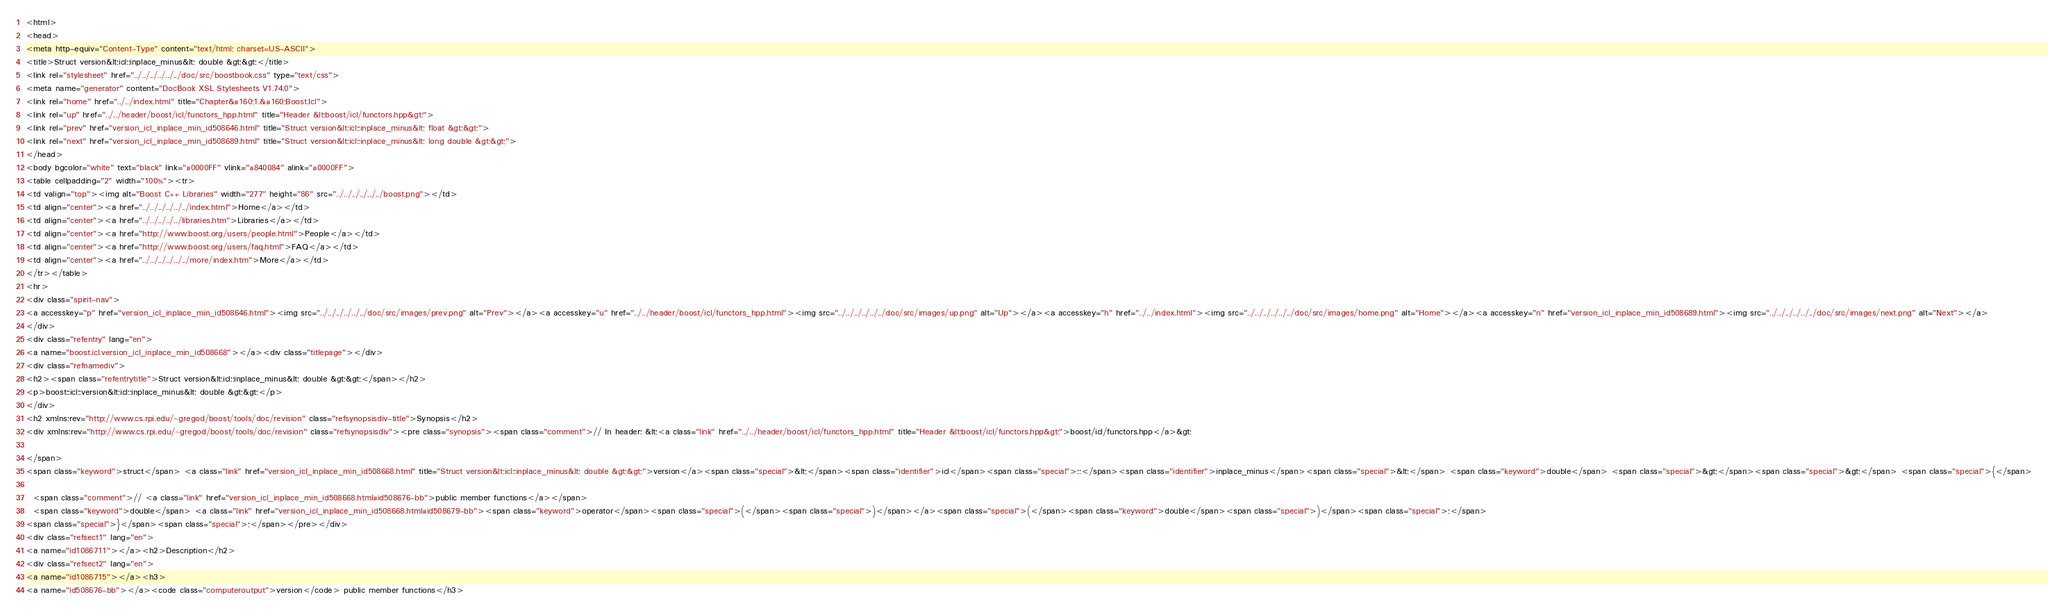<code> <loc_0><loc_0><loc_500><loc_500><_HTML_><html>
<head>
<meta http-equiv="Content-Type" content="text/html; charset=US-ASCII">
<title>Struct version&lt;icl::inplace_minus&lt; double &gt;&gt;</title>
<link rel="stylesheet" href="../../../../../../doc/src/boostbook.css" type="text/css">
<meta name="generator" content="DocBook XSL Stylesheets V1.74.0">
<link rel="home" href="../../index.html" title="Chapter&#160;1.&#160;Boost.Icl">
<link rel="up" href="../../header/boost/icl/functors_hpp.html" title="Header &lt;boost/icl/functors.hpp&gt;">
<link rel="prev" href="version_icl_inplace_min_id508646.html" title="Struct version&lt;icl::inplace_minus&lt; float &gt;&gt;">
<link rel="next" href="version_icl_inplace_min_id508689.html" title="Struct version&lt;icl::inplace_minus&lt; long double &gt;&gt;">
</head>
<body bgcolor="white" text="black" link="#0000FF" vlink="#840084" alink="#0000FF">
<table cellpadding="2" width="100%"><tr>
<td valign="top"><img alt="Boost C++ Libraries" width="277" height="86" src="../../../../../../boost.png"></td>
<td align="center"><a href="../../../../../../index.html">Home</a></td>
<td align="center"><a href="../../../../../libraries.htm">Libraries</a></td>
<td align="center"><a href="http://www.boost.org/users/people.html">People</a></td>
<td align="center"><a href="http://www.boost.org/users/faq.html">FAQ</a></td>
<td align="center"><a href="../../../../../../more/index.htm">More</a></td>
</tr></table>
<hr>
<div class="spirit-nav">
<a accesskey="p" href="version_icl_inplace_min_id508646.html"><img src="../../../../../../doc/src/images/prev.png" alt="Prev"></a><a accesskey="u" href="../../header/boost/icl/functors_hpp.html"><img src="../../../../../../doc/src/images/up.png" alt="Up"></a><a accesskey="h" href="../../index.html"><img src="../../../../../../doc/src/images/home.png" alt="Home"></a><a accesskey="n" href="version_icl_inplace_min_id508689.html"><img src="../../../../../../doc/src/images/next.png" alt="Next"></a>
</div>
<div class="refentry" lang="en">
<a name="boost.icl.version_icl_inplace_min_id508668"></a><div class="titlepage"></div>
<div class="refnamediv">
<h2><span class="refentrytitle">Struct version&lt;icl::inplace_minus&lt; double &gt;&gt;</span></h2>
<p>boost::icl::version&lt;icl::inplace_minus&lt; double &gt;&gt;</p>
</div>
<h2 xmlns:rev="http://www.cs.rpi.edu/~gregod/boost/tools/doc/revision" class="refsynopsisdiv-title">Synopsis</h2>
<div xmlns:rev="http://www.cs.rpi.edu/~gregod/boost/tools/doc/revision" class="refsynopsisdiv"><pre class="synopsis"><span class="comment">// In header: &lt;<a class="link" href="../../header/boost/icl/functors_hpp.html" title="Header &lt;boost/icl/functors.hpp&gt;">boost/icl/functors.hpp</a>&gt;

</span>
<span class="keyword">struct</span> <a class="link" href="version_icl_inplace_min_id508668.html" title="Struct version&lt;icl::inplace_minus&lt; double &gt;&gt;">version</a><span class="special">&lt;</span><span class="identifier">icl</span><span class="special">::</span><span class="identifier">inplace_minus</span><span class="special">&lt;</span> <span class="keyword">double</span> <span class="special">&gt;</span><span class="special">&gt;</span> <span class="special">{</span>

  <span class="comment">// <a class="link" href="version_icl_inplace_min_id508668.html#id508676-bb">public member functions</a></span>
  <span class="keyword">double</span> <a class="link" href="version_icl_inplace_min_id508668.html#id508679-bb"><span class="keyword">operator</span><span class="special">(</span><span class="special">)</span></a><span class="special">(</span><span class="keyword">double</span><span class="special">)</span><span class="special">;</span>
<span class="special">}</span><span class="special">;</span></pre></div>
<div class="refsect1" lang="en">
<a name="id1086711"></a><h2>Description</h2>
<div class="refsect2" lang="en">
<a name="id1086715"></a><h3>
<a name="id508676-bb"></a><code class="computeroutput">version</code> public member functions</h3></code> 